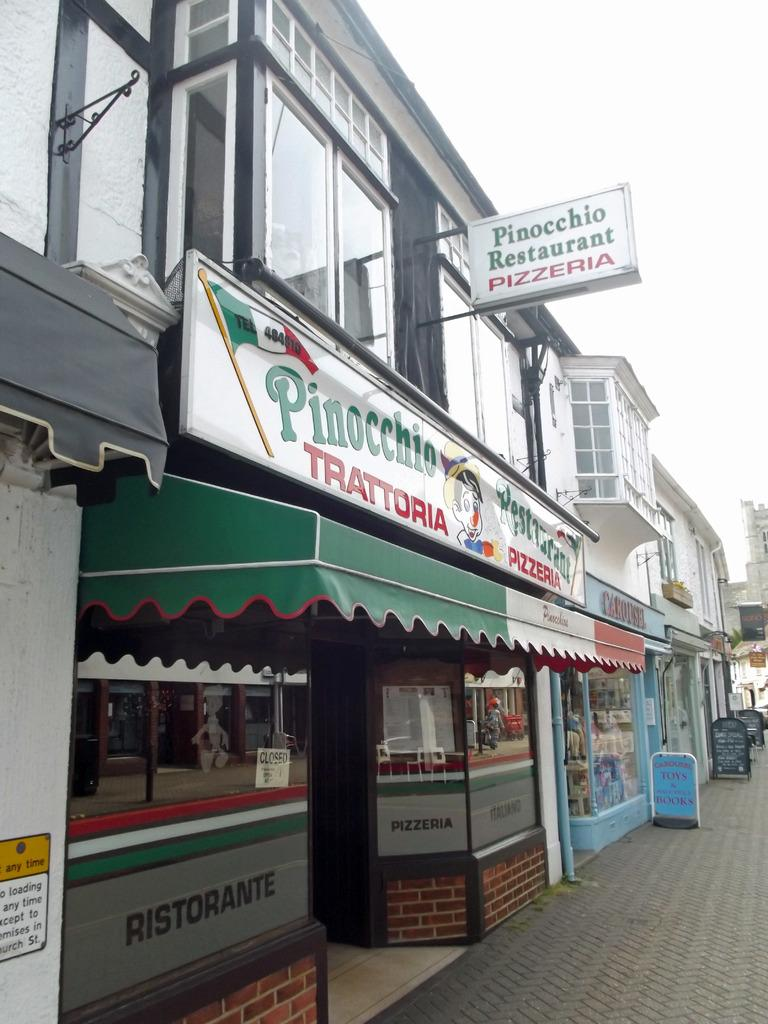<image>
Summarize the visual content of the image. A pizza restaurant named Pinocchio Restaurant in a quiet street. 